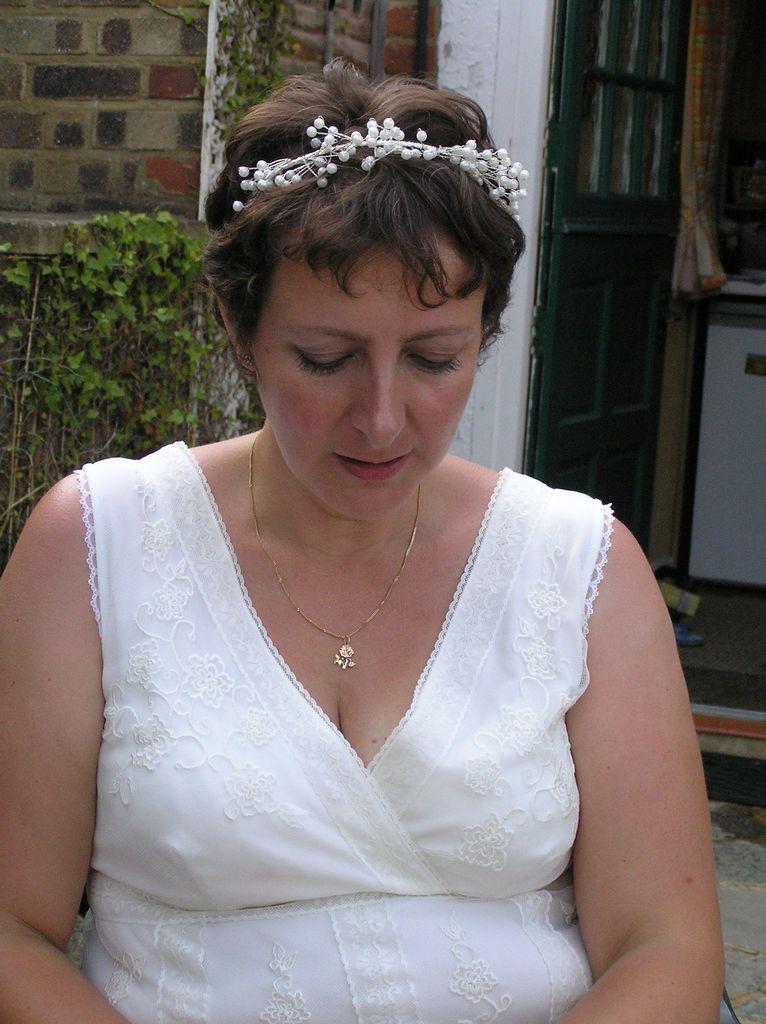Could you give a brief overview of what you see in this image? In this image in the foreground there is one woman and in the background there is a house, plants, door, curtain and some other objects. 